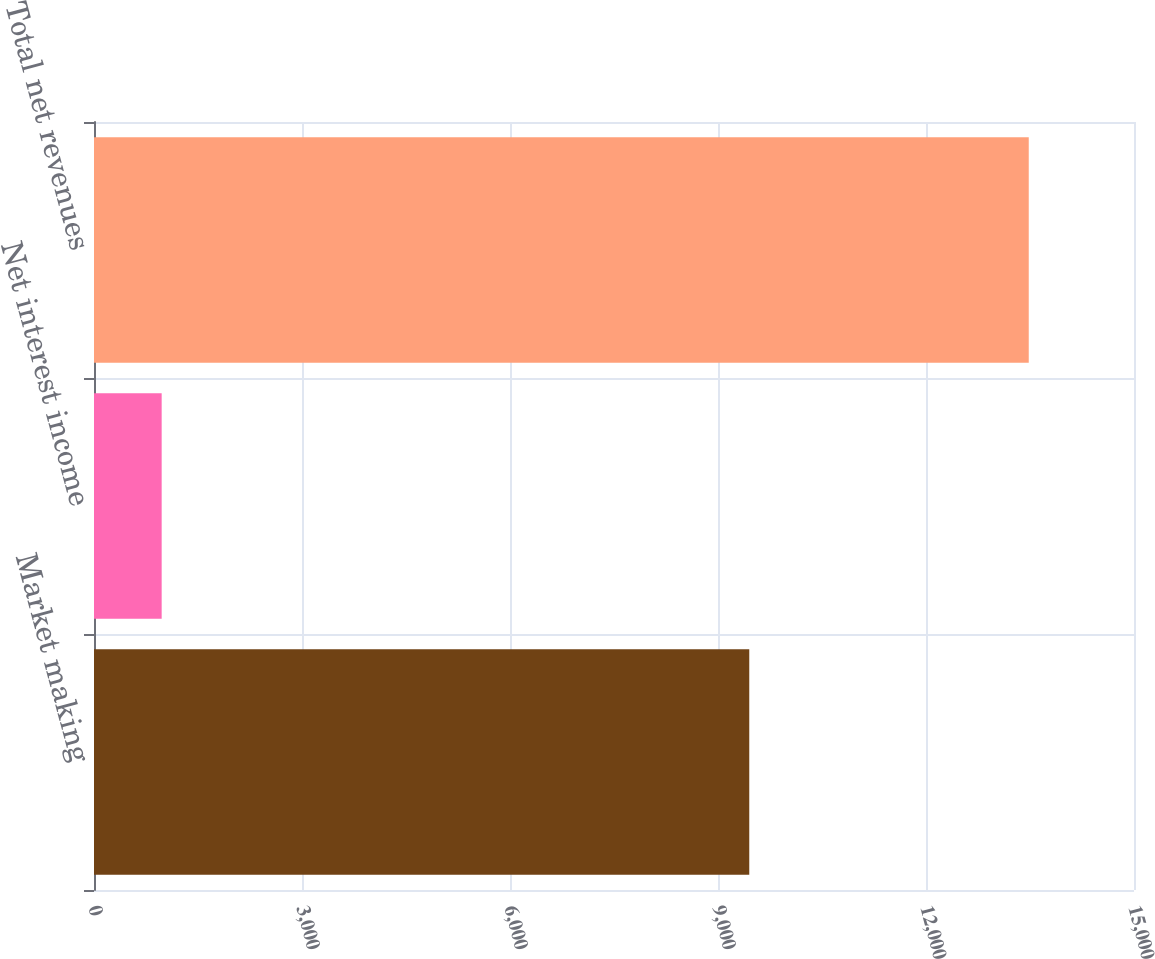<chart> <loc_0><loc_0><loc_500><loc_500><bar_chart><fcel>Market making<fcel>Net interest income<fcel>Total net revenues<nl><fcel>9451<fcel>976<fcel>13482<nl></chart> 